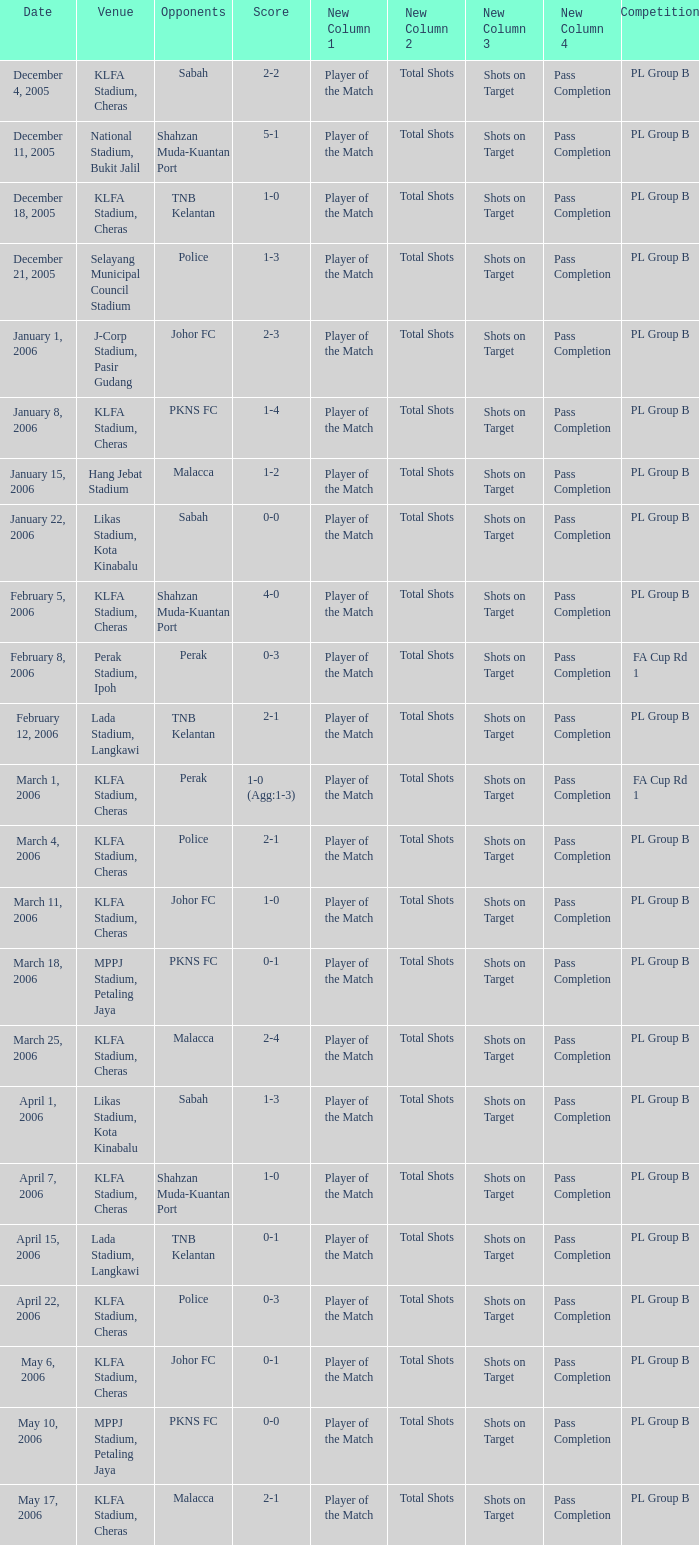Which Date has a Competition of pl group b, and Opponents of police, and a Venue of selayang municipal council stadium? December 21, 2005. 